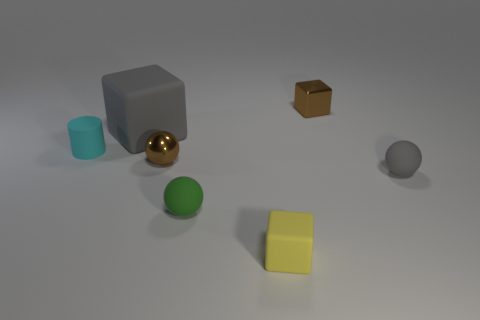Add 3 yellow cubes. How many objects exist? 10 Subtract all balls. How many objects are left? 4 Add 7 gray blocks. How many gray blocks exist? 8 Subtract 0 cyan blocks. How many objects are left? 7 Subtract all green rubber spheres. Subtract all brown metallic blocks. How many objects are left? 5 Add 3 green things. How many green things are left? 4 